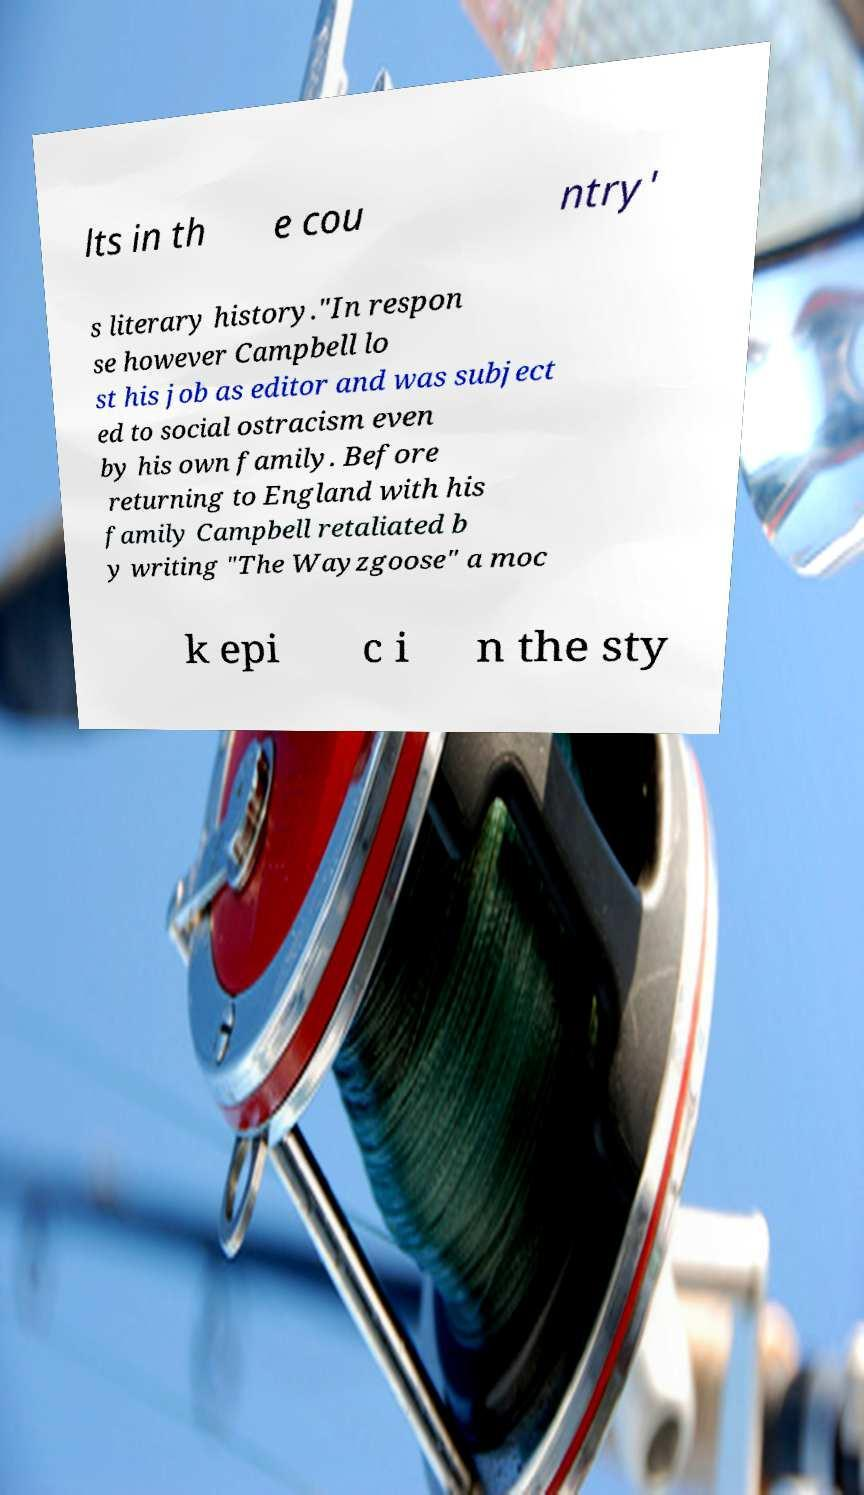I need the written content from this picture converted into text. Can you do that? lts in th e cou ntry' s literary history."In respon se however Campbell lo st his job as editor and was subject ed to social ostracism even by his own family. Before returning to England with his family Campbell retaliated b y writing "The Wayzgoose" a moc k epi c i n the sty 